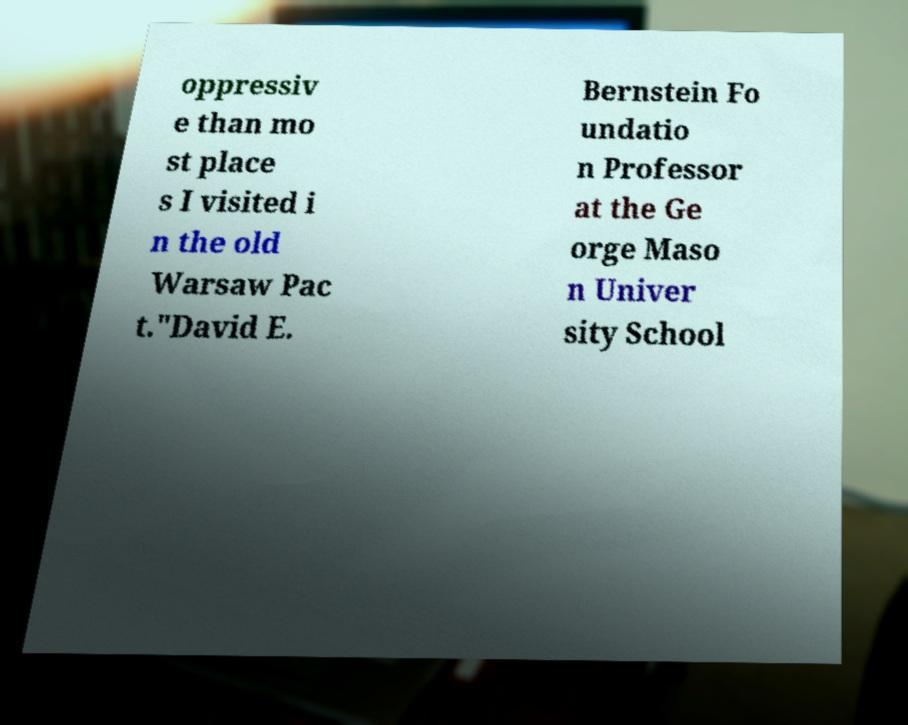What messages or text are displayed in this image? I need them in a readable, typed format. oppressiv e than mo st place s I visited i n the old Warsaw Pac t."David E. Bernstein Fo undatio n Professor at the Ge orge Maso n Univer sity School 